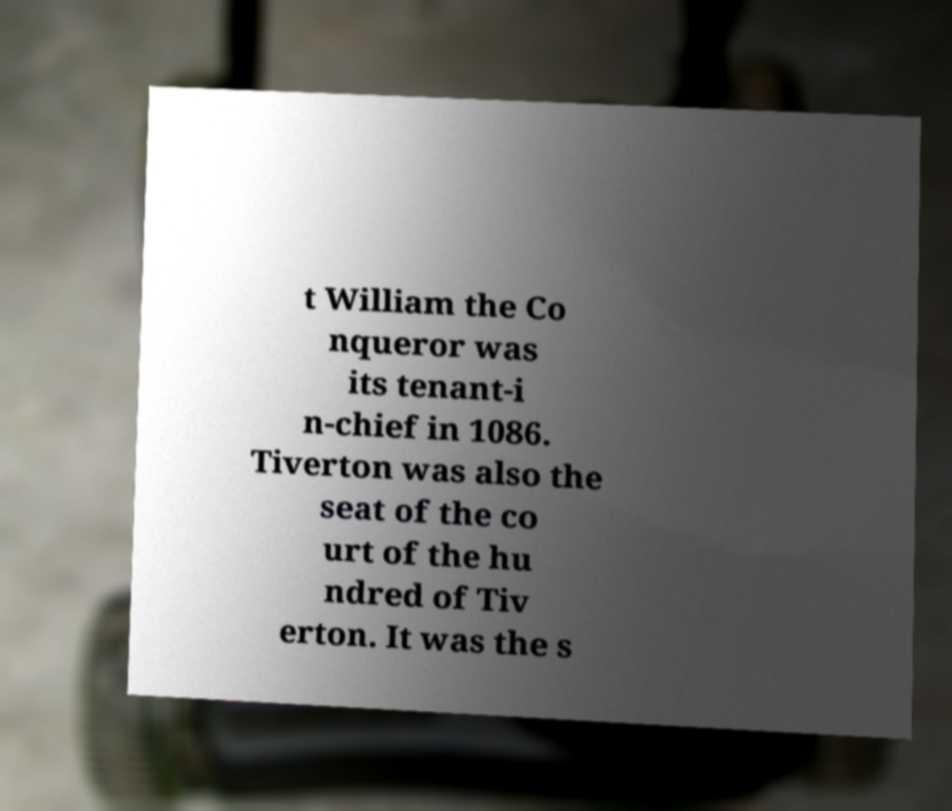I need the written content from this picture converted into text. Can you do that? t William the Co nqueror was its tenant-i n-chief in 1086. Tiverton was also the seat of the co urt of the hu ndred of Tiv erton. It was the s 